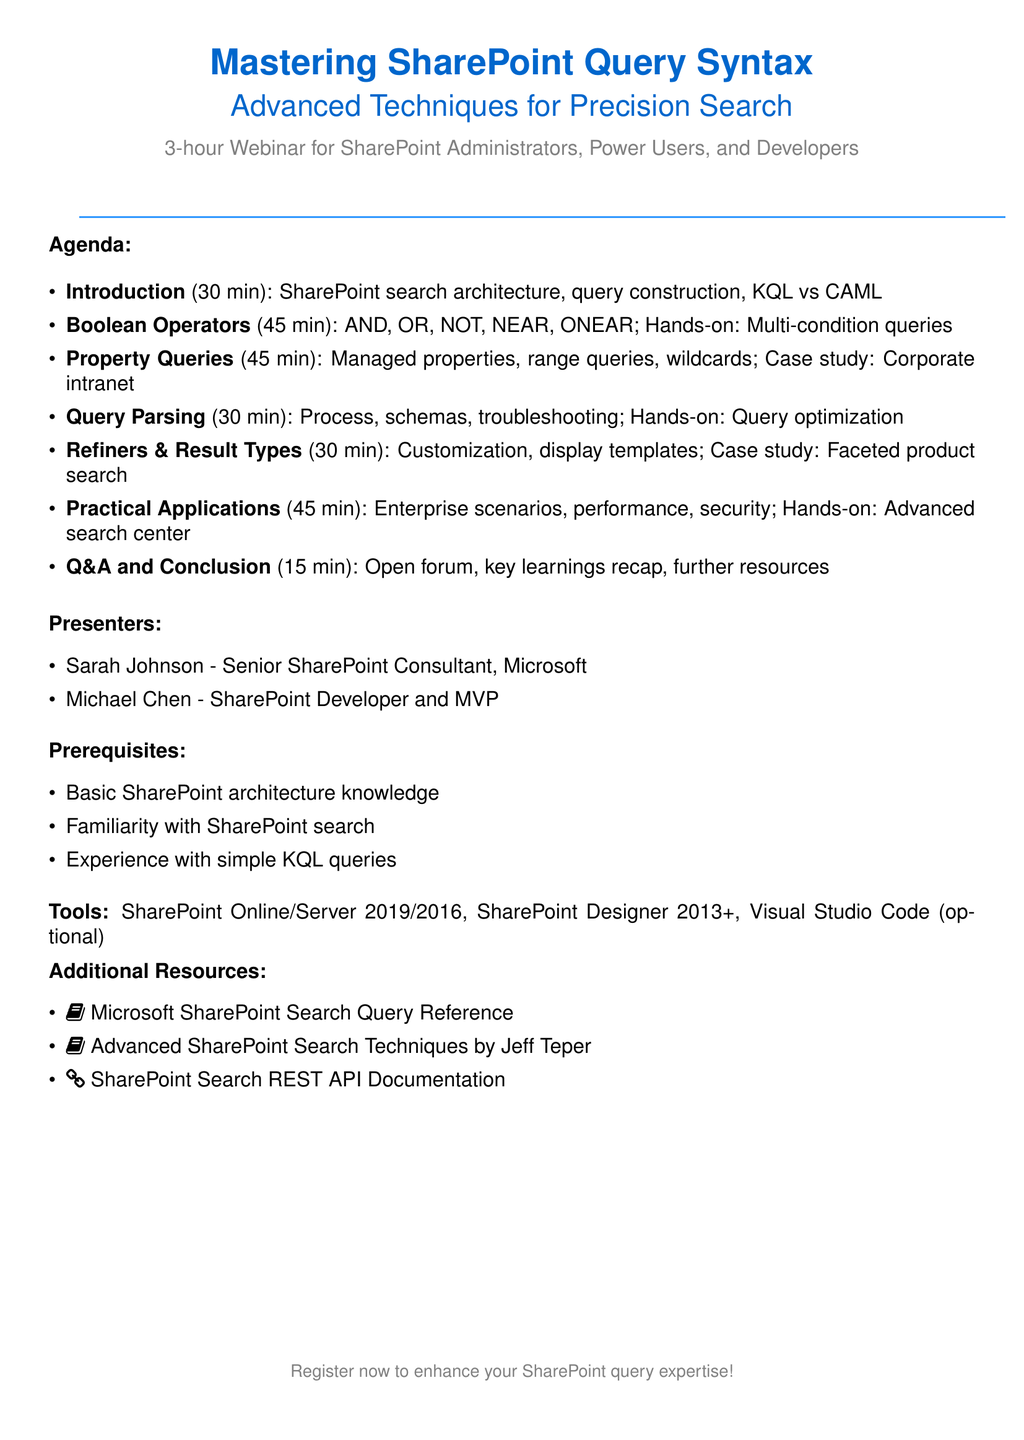What is the title of the webinar? The title of the webinar is stated at the top of the agenda, clearly indicating the focus on mastering SharePoint query syntax.
Answer: Mastering SharePoint Query Syntax: Advanced Techniques for Precision Search Who is one of the presenters? The document lists the presenters towards the end, detailing their roles and expertise.
Answer: Sarah Johnson How long is the webinar? The duration of the webinar is specified in the introduction section.
Answer: 3 hours What is one prerequisite for attending the webinar? Prerequisites are listed before the tools section, providing necessary background knowledge for attendees.
Answer: Basic understanding of SharePoint architecture Which section covers Boolean operators? Sections in the agenda provide titles and topics, indicating where specific subjects are addressed.
Answer: Deep Dive into Boolean Operators How many minutes are allocated for the Q&A session? The time allocated for each agenda section is clearly marked alongside the titles.
Answer: 15 minutes What type of hands-on exercise is mentioned? Hands-on exercises are specified in various sections to provide practical experience, highlighting the interactive aspect of the webinar.
Answer: Constructing multi-condition queries What tool is optional for advanced customizations? The tools section outlines the required and optional software for participants to use during the webinar.
Answer: Visual Studio Code Which case study is included in the agenda? A case study is mentioned under the advanced property queries section, showcasing practical application in a larger context.
Answer: Optimizing document retrieval in a large corporate intranet 